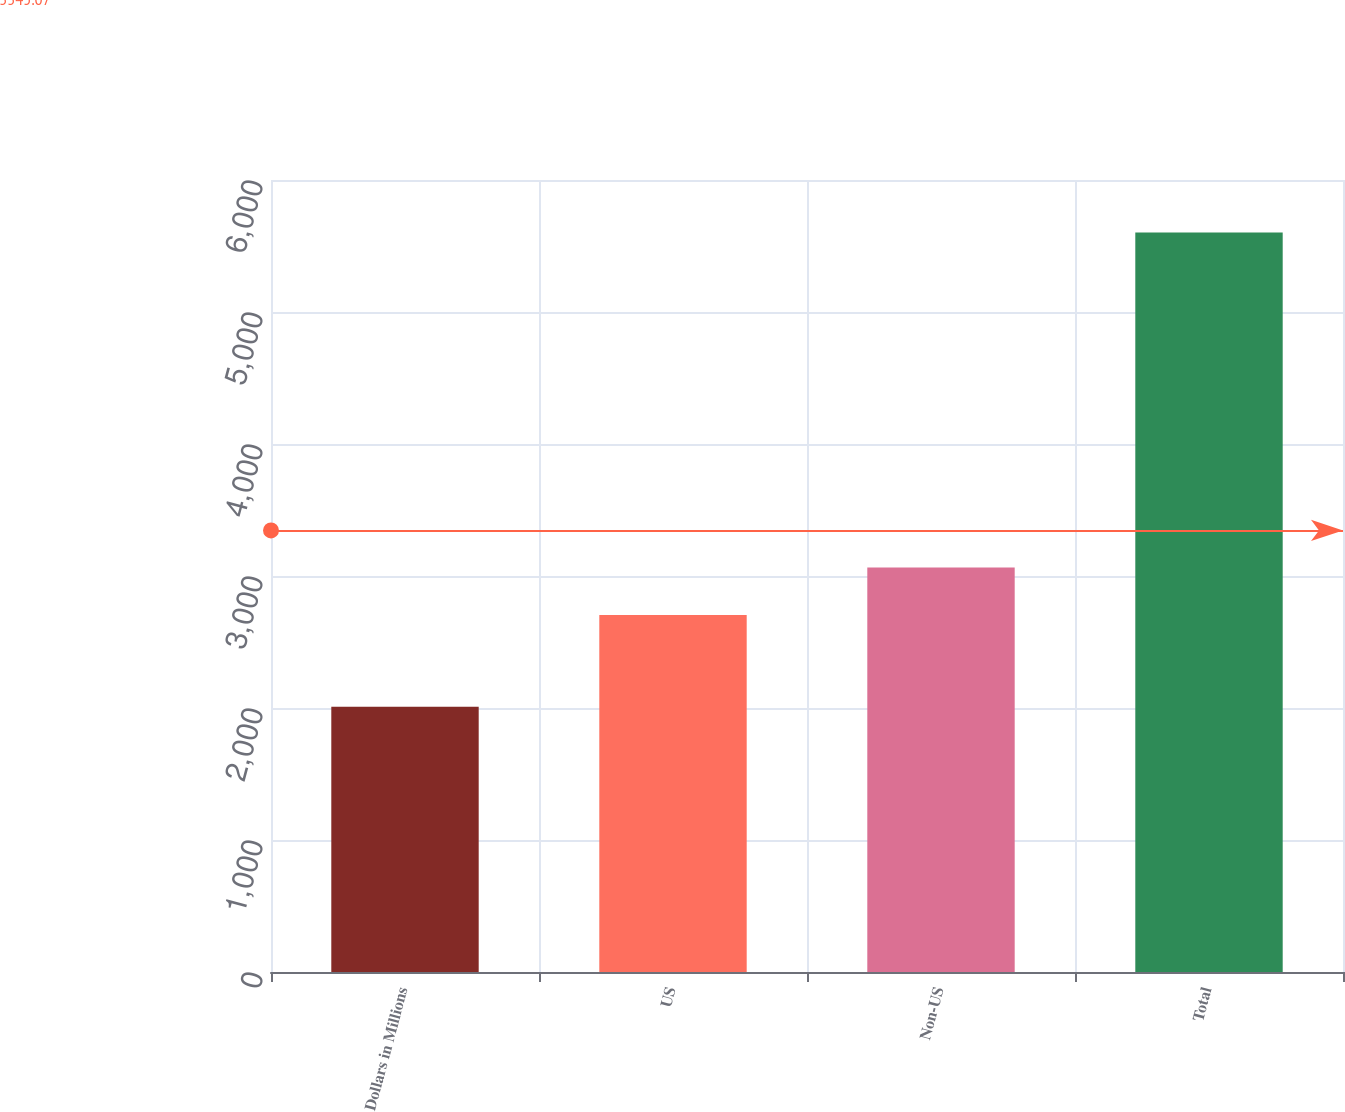Convert chart to OTSL. <chart><loc_0><loc_0><loc_500><loc_500><bar_chart><fcel>Dollars in Millions<fcel>US<fcel>Non-US<fcel>Total<nl><fcel>2009<fcel>2705<fcel>3064.3<fcel>5602<nl></chart> 